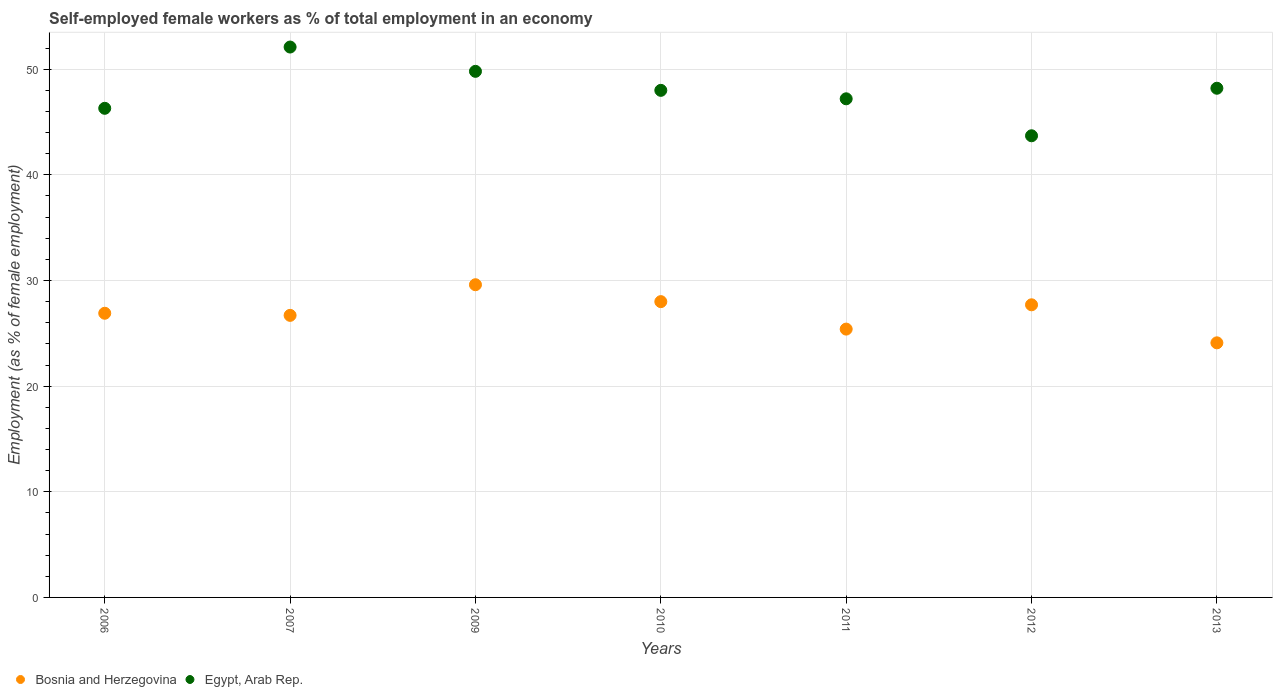How many different coloured dotlines are there?
Offer a very short reply. 2. What is the percentage of self-employed female workers in Egypt, Arab Rep. in 2006?
Give a very brief answer. 46.3. Across all years, what is the maximum percentage of self-employed female workers in Egypt, Arab Rep.?
Your response must be concise. 52.1. Across all years, what is the minimum percentage of self-employed female workers in Bosnia and Herzegovina?
Offer a very short reply. 24.1. In which year was the percentage of self-employed female workers in Egypt, Arab Rep. maximum?
Offer a very short reply. 2007. What is the total percentage of self-employed female workers in Bosnia and Herzegovina in the graph?
Keep it short and to the point. 188.4. What is the difference between the percentage of self-employed female workers in Bosnia and Herzegovina in 2007 and that in 2010?
Offer a very short reply. -1.3. What is the difference between the percentage of self-employed female workers in Bosnia and Herzegovina in 2006 and the percentage of self-employed female workers in Egypt, Arab Rep. in 2009?
Give a very brief answer. -22.9. What is the average percentage of self-employed female workers in Egypt, Arab Rep. per year?
Offer a terse response. 47.9. In the year 2007, what is the difference between the percentage of self-employed female workers in Bosnia and Herzegovina and percentage of self-employed female workers in Egypt, Arab Rep.?
Your answer should be compact. -25.4. In how many years, is the percentage of self-employed female workers in Bosnia and Herzegovina greater than 50 %?
Offer a terse response. 0. What is the ratio of the percentage of self-employed female workers in Egypt, Arab Rep. in 2009 to that in 2010?
Your answer should be very brief. 1.04. Is the difference between the percentage of self-employed female workers in Bosnia and Herzegovina in 2007 and 2013 greater than the difference between the percentage of self-employed female workers in Egypt, Arab Rep. in 2007 and 2013?
Your answer should be compact. No. What is the difference between the highest and the second highest percentage of self-employed female workers in Bosnia and Herzegovina?
Offer a terse response. 1.6. What is the difference between the highest and the lowest percentage of self-employed female workers in Egypt, Arab Rep.?
Ensure brevity in your answer.  8.4. Is the percentage of self-employed female workers in Bosnia and Herzegovina strictly greater than the percentage of self-employed female workers in Egypt, Arab Rep. over the years?
Your answer should be compact. No. How many years are there in the graph?
Provide a short and direct response. 7. Are the values on the major ticks of Y-axis written in scientific E-notation?
Keep it short and to the point. No. Does the graph contain any zero values?
Make the answer very short. No. Where does the legend appear in the graph?
Your response must be concise. Bottom left. How are the legend labels stacked?
Keep it short and to the point. Horizontal. What is the title of the graph?
Your response must be concise. Self-employed female workers as % of total employment in an economy. What is the label or title of the X-axis?
Your answer should be compact. Years. What is the label or title of the Y-axis?
Your response must be concise. Employment (as % of female employment). What is the Employment (as % of female employment) of Bosnia and Herzegovina in 2006?
Keep it short and to the point. 26.9. What is the Employment (as % of female employment) in Egypt, Arab Rep. in 2006?
Your answer should be very brief. 46.3. What is the Employment (as % of female employment) of Bosnia and Herzegovina in 2007?
Keep it short and to the point. 26.7. What is the Employment (as % of female employment) in Egypt, Arab Rep. in 2007?
Give a very brief answer. 52.1. What is the Employment (as % of female employment) in Bosnia and Herzegovina in 2009?
Offer a terse response. 29.6. What is the Employment (as % of female employment) of Egypt, Arab Rep. in 2009?
Give a very brief answer. 49.8. What is the Employment (as % of female employment) of Egypt, Arab Rep. in 2010?
Your response must be concise. 48. What is the Employment (as % of female employment) in Bosnia and Herzegovina in 2011?
Keep it short and to the point. 25.4. What is the Employment (as % of female employment) in Egypt, Arab Rep. in 2011?
Your answer should be compact. 47.2. What is the Employment (as % of female employment) in Bosnia and Herzegovina in 2012?
Your answer should be very brief. 27.7. What is the Employment (as % of female employment) in Egypt, Arab Rep. in 2012?
Your answer should be compact. 43.7. What is the Employment (as % of female employment) of Bosnia and Herzegovina in 2013?
Your response must be concise. 24.1. What is the Employment (as % of female employment) of Egypt, Arab Rep. in 2013?
Ensure brevity in your answer.  48.2. Across all years, what is the maximum Employment (as % of female employment) in Bosnia and Herzegovina?
Your response must be concise. 29.6. Across all years, what is the maximum Employment (as % of female employment) in Egypt, Arab Rep.?
Keep it short and to the point. 52.1. Across all years, what is the minimum Employment (as % of female employment) of Bosnia and Herzegovina?
Your answer should be compact. 24.1. Across all years, what is the minimum Employment (as % of female employment) of Egypt, Arab Rep.?
Your answer should be very brief. 43.7. What is the total Employment (as % of female employment) of Bosnia and Herzegovina in the graph?
Make the answer very short. 188.4. What is the total Employment (as % of female employment) of Egypt, Arab Rep. in the graph?
Your answer should be compact. 335.3. What is the difference between the Employment (as % of female employment) of Bosnia and Herzegovina in 2006 and that in 2007?
Provide a succinct answer. 0.2. What is the difference between the Employment (as % of female employment) of Bosnia and Herzegovina in 2006 and that in 2009?
Your response must be concise. -2.7. What is the difference between the Employment (as % of female employment) in Egypt, Arab Rep. in 2006 and that in 2009?
Offer a very short reply. -3.5. What is the difference between the Employment (as % of female employment) in Bosnia and Herzegovina in 2006 and that in 2010?
Keep it short and to the point. -1.1. What is the difference between the Employment (as % of female employment) in Bosnia and Herzegovina in 2006 and that in 2011?
Ensure brevity in your answer.  1.5. What is the difference between the Employment (as % of female employment) in Bosnia and Herzegovina in 2006 and that in 2012?
Make the answer very short. -0.8. What is the difference between the Employment (as % of female employment) of Bosnia and Herzegovina in 2006 and that in 2013?
Keep it short and to the point. 2.8. What is the difference between the Employment (as % of female employment) of Bosnia and Herzegovina in 2007 and that in 2009?
Provide a succinct answer. -2.9. What is the difference between the Employment (as % of female employment) of Egypt, Arab Rep. in 2007 and that in 2009?
Provide a short and direct response. 2.3. What is the difference between the Employment (as % of female employment) of Bosnia and Herzegovina in 2007 and that in 2011?
Offer a terse response. 1.3. What is the difference between the Employment (as % of female employment) in Bosnia and Herzegovina in 2007 and that in 2013?
Offer a very short reply. 2.6. What is the difference between the Employment (as % of female employment) in Egypt, Arab Rep. in 2007 and that in 2013?
Offer a terse response. 3.9. What is the difference between the Employment (as % of female employment) of Bosnia and Herzegovina in 2009 and that in 2010?
Offer a terse response. 1.6. What is the difference between the Employment (as % of female employment) of Egypt, Arab Rep. in 2009 and that in 2010?
Provide a succinct answer. 1.8. What is the difference between the Employment (as % of female employment) in Bosnia and Herzegovina in 2009 and that in 2011?
Offer a terse response. 4.2. What is the difference between the Employment (as % of female employment) of Bosnia and Herzegovina in 2009 and that in 2012?
Your answer should be compact. 1.9. What is the difference between the Employment (as % of female employment) of Bosnia and Herzegovina in 2010 and that in 2011?
Provide a short and direct response. 2.6. What is the difference between the Employment (as % of female employment) in Egypt, Arab Rep. in 2010 and that in 2011?
Offer a terse response. 0.8. What is the difference between the Employment (as % of female employment) of Egypt, Arab Rep. in 2010 and that in 2012?
Provide a succinct answer. 4.3. What is the difference between the Employment (as % of female employment) in Egypt, Arab Rep. in 2010 and that in 2013?
Your response must be concise. -0.2. What is the difference between the Employment (as % of female employment) of Bosnia and Herzegovina in 2011 and that in 2012?
Offer a very short reply. -2.3. What is the difference between the Employment (as % of female employment) of Egypt, Arab Rep. in 2011 and that in 2012?
Provide a short and direct response. 3.5. What is the difference between the Employment (as % of female employment) of Bosnia and Herzegovina in 2012 and that in 2013?
Offer a very short reply. 3.6. What is the difference between the Employment (as % of female employment) of Egypt, Arab Rep. in 2012 and that in 2013?
Your response must be concise. -4.5. What is the difference between the Employment (as % of female employment) in Bosnia and Herzegovina in 2006 and the Employment (as % of female employment) in Egypt, Arab Rep. in 2007?
Offer a very short reply. -25.2. What is the difference between the Employment (as % of female employment) of Bosnia and Herzegovina in 2006 and the Employment (as % of female employment) of Egypt, Arab Rep. in 2009?
Ensure brevity in your answer.  -22.9. What is the difference between the Employment (as % of female employment) of Bosnia and Herzegovina in 2006 and the Employment (as % of female employment) of Egypt, Arab Rep. in 2010?
Keep it short and to the point. -21.1. What is the difference between the Employment (as % of female employment) of Bosnia and Herzegovina in 2006 and the Employment (as % of female employment) of Egypt, Arab Rep. in 2011?
Provide a short and direct response. -20.3. What is the difference between the Employment (as % of female employment) in Bosnia and Herzegovina in 2006 and the Employment (as % of female employment) in Egypt, Arab Rep. in 2012?
Give a very brief answer. -16.8. What is the difference between the Employment (as % of female employment) in Bosnia and Herzegovina in 2006 and the Employment (as % of female employment) in Egypt, Arab Rep. in 2013?
Make the answer very short. -21.3. What is the difference between the Employment (as % of female employment) of Bosnia and Herzegovina in 2007 and the Employment (as % of female employment) of Egypt, Arab Rep. in 2009?
Give a very brief answer. -23.1. What is the difference between the Employment (as % of female employment) of Bosnia and Herzegovina in 2007 and the Employment (as % of female employment) of Egypt, Arab Rep. in 2010?
Your answer should be compact. -21.3. What is the difference between the Employment (as % of female employment) in Bosnia and Herzegovina in 2007 and the Employment (as % of female employment) in Egypt, Arab Rep. in 2011?
Provide a short and direct response. -20.5. What is the difference between the Employment (as % of female employment) of Bosnia and Herzegovina in 2007 and the Employment (as % of female employment) of Egypt, Arab Rep. in 2012?
Your answer should be compact. -17. What is the difference between the Employment (as % of female employment) in Bosnia and Herzegovina in 2007 and the Employment (as % of female employment) in Egypt, Arab Rep. in 2013?
Provide a short and direct response. -21.5. What is the difference between the Employment (as % of female employment) in Bosnia and Herzegovina in 2009 and the Employment (as % of female employment) in Egypt, Arab Rep. in 2010?
Provide a short and direct response. -18.4. What is the difference between the Employment (as % of female employment) of Bosnia and Herzegovina in 2009 and the Employment (as % of female employment) of Egypt, Arab Rep. in 2011?
Your answer should be very brief. -17.6. What is the difference between the Employment (as % of female employment) in Bosnia and Herzegovina in 2009 and the Employment (as % of female employment) in Egypt, Arab Rep. in 2012?
Offer a very short reply. -14.1. What is the difference between the Employment (as % of female employment) of Bosnia and Herzegovina in 2009 and the Employment (as % of female employment) of Egypt, Arab Rep. in 2013?
Provide a short and direct response. -18.6. What is the difference between the Employment (as % of female employment) of Bosnia and Herzegovina in 2010 and the Employment (as % of female employment) of Egypt, Arab Rep. in 2011?
Keep it short and to the point. -19.2. What is the difference between the Employment (as % of female employment) in Bosnia and Herzegovina in 2010 and the Employment (as % of female employment) in Egypt, Arab Rep. in 2012?
Ensure brevity in your answer.  -15.7. What is the difference between the Employment (as % of female employment) in Bosnia and Herzegovina in 2010 and the Employment (as % of female employment) in Egypt, Arab Rep. in 2013?
Ensure brevity in your answer.  -20.2. What is the difference between the Employment (as % of female employment) of Bosnia and Herzegovina in 2011 and the Employment (as % of female employment) of Egypt, Arab Rep. in 2012?
Your answer should be compact. -18.3. What is the difference between the Employment (as % of female employment) in Bosnia and Herzegovina in 2011 and the Employment (as % of female employment) in Egypt, Arab Rep. in 2013?
Keep it short and to the point. -22.8. What is the difference between the Employment (as % of female employment) in Bosnia and Herzegovina in 2012 and the Employment (as % of female employment) in Egypt, Arab Rep. in 2013?
Ensure brevity in your answer.  -20.5. What is the average Employment (as % of female employment) in Bosnia and Herzegovina per year?
Offer a very short reply. 26.91. What is the average Employment (as % of female employment) in Egypt, Arab Rep. per year?
Ensure brevity in your answer.  47.9. In the year 2006, what is the difference between the Employment (as % of female employment) in Bosnia and Herzegovina and Employment (as % of female employment) in Egypt, Arab Rep.?
Give a very brief answer. -19.4. In the year 2007, what is the difference between the Employment (as % of female employment) of Bosnia and Herzegovina and Employment (as % of female employment) of Egypt, Arab Rep.?
Give a very brief answer. -25.4. In the year 2009, what is the difference between the Employment (as % of female employment) of Bosnia and Herzegovina and Employment (as % of female employment) of Egypt, Arab Rep.?
Give a very brief answer. -20.2. In the year 2010, what is the difference between the Employment (as % of female employment) in Bosnia and Herzegovina and Employment (as % of female employment) in Egypt, Arab Rep.?
Offer a terse response. -20. In the year 2011, what is the difference between the Employment (as % of female employment) in Bosnia and Herzegovina and Employment (as % of female employment) in Egypt, Arab Rep.?
Your answer should be compact. -21.8. In the year 2012, what is the difference between the Employment (as % of female employment) of Bosnia and Herzegovina and Employment (as % of female employment) of Egypt, Arab Rep.?
Provide a short and direct response. -16. In the year 2013, what is the difference between the Employment (as % of female employment) of Bosnia and Herzegovina and Employment (as % of female employment) of Egypt, Arab Rep.?
Your response must be concise. -24.1. What is the ratio of the Employment (as % of female employment) in Bosnia and Herzegovina in 2006 to that in 2007?
Your answer should be very brief. 1.01. What is the ratio of the Employment (as % of female employment) in Egypt, Arab Rep. in 2006 to that in 2007?
Make the answer very short. 0.89. What is the ratio of the Employment (as % of female employment) in Bosnia and Herzegovina in 2006 to that in 2009?
Your response must be concise. 0.91. What is the ratio of the Employment (as % of female employment) of Egypt, Arab Rep. in 2006 to that in 2009?
Provide a succinct answer. 0.93. What is the ratio of the Employment (as % of female employment) of Bosnia and Herzegovina in 2006 to that in 2010?
Your answer should be very brief. 0.96. What is the ratio of the Employment (as % of female employment) of Egypt, Arab Rep. in 2006 to that in 2010?
Give a very brief answer. 0.96. What is the ratio of the Employment (as % of female employment) in Bosnia and Herzegovina in 2006 to that in 2011?
Offer a very short reply. 1.06. What is the ratio of the Employment (as % of female employment) of Egypt, Arab Rep. in 2006 to that in 2011?
Your answer should be compact. 0.98. What is the ratio of the Employment (as % of female employment) of Bosnia and Herzegovina in 2006 to that in 2012?
Ensure brevity in your answer.  0.97. What is the ratio of the Employment (as % of female employment) of Egypt, Arab Rep. in 2006 to that in 2012?
Your answer should be compact. 1.06. What is the ratio of the Employment (as % of female employment) in Bosnia and Herzegovina in 2006 to that in 2013?
Keep it short and to the point. 1.12. What is the ratio of the Employment (as % of female employment) in Egypt, Arab Rep. in 2006 to that in 2013?
Your response must be concise. 0.96. What is the ratio of the Employment (as % of female employment) of Bosnia and Herzegovina in 2007 to that in 2009?
Make the answer very short. 0.9. What is the ratio of the Employment (as % of female employment) in Egypt, Arab Rep. in 2007 to that in 2009?
Make the answer very short. 1.05. What is the ratio of the Employment (as % of female employment) in Bosnia and Herzegovina in 2007 to that in 2010?
Make the answer very short. 0.95. What is the ratio of the Employment (as % of female employment) of Egypt, Arab Rep. in 2007 to that in 2010?
Ensure brevity in your answer.  1.09. What is the ratio of the Employment (as % of female employment) in Bosnia and Herzegovina in 2007 to that in 2011?
Ensure brevity in your answer.  1.05. What is the ratio of the Employment (as % of female employment) in Egypt, Arab Rep. in 2007 to that in 2011?
Your response must be concise. 1.1. What is the ratio of the Employment (as % of female employment) of Bosnia and Herzegovina in 2007 to that in 2012?
Your answer should be compact. 0.96. What is the ratio of the Employment (as % of female employment) of Egypt, Arab Rep. in 2007 to that in 2012?
Give a very brief answer. 1.19. What is the ratio of the Employment (as % of female employment) in Bosnia and Herzegovina in 2007 to that in 2013?
Make the answer very short. 1.11. What is the ratio of the Employment (as % of female employment) in Egypt, Arab Rep. in 2007 to that in 2013?
Make the answer very short. 1.08. What is the ratio of the Employment (as % of female employment) of Bosnia and Herzegovina in 2009 to that in 2010?
Ensure brevity in your answer.  1.06. What is the ratio of the Employment (as % of female employment) in Egypt, Arab Rep. in 2009 to that in 2010?
Your answer should be compact. 1.04. What is the ratio of the Employment (as % of female employment) in Bosnia and Herzegovina in 2009 to that in 2011?
Give a very brief answer. 1.17. What is the ratio of the Employment (as % of female employment) in Egypt, Arab Rep. in 2009 to that in 2011?
Offer a terse response. 1.06. What is the ratio of the Employment (as % of female employment) in Bosnia and Herzegovina in 2009 to that in 2012?
Keep it short and to the point. 1.07. What is the ratio of the Employment (as % of female employment) of Egypt, Arab Rep. in 2009 to that in 2012?
Ensure brevity in your answer.  1.14. What is the ratio of the Employment (as % of female employment) of Bosnia and Herzegovina in 2009 to that in 2013?
Provide a succinct answer. 1.23. What is the ratio of the Employment (as % of female employment) in Egypt, Arab Rep. in 2009 to that in 2013?
Make the answer very short. 1.03. What is the ratio of the Employment (as % of female employment) of Bosnia and Herzegovina in 2010 to that in 2011?
Make the answer very short. 1.1. What is the ratio of the Employment (as % of female employment) in Egypt, Arab Rep. in 2010 to that in 2011?
Your answer should be compact. 1.02. What is the ratio of the Employment (as % of female employment) in Bosnia and Herzegovina in 2010 to that in 2012?
Offer a very short reply. 1.01. What is the ratio of the Employment (as % of female employment) of Egypt, Arab Rep. in 2010 to that in 2012?
Keep it short and to the point. 1.1. What is the ratio of the Employment (as % of female employment) of Bosnia and Herzegovina in 2010 to that in 2013?
Provide a short and direct response. 1.16. What is the ratio of the Employment (as % of female employment) of Bosnia and Herzegovina in 2011 to that in 2012?
Provide a succinct answer. 0.92. What is the ratio of the Employment (as % of female employment) in Egypt, Arab Rep. in 2011 to that in 2012?
Ensure brevity in your answer.  1.08. What is the ratio of the Employment (as % of female employment) in Bosnia and Herzegovina in 2011 to that in 2013?
Offer a very short reply. 1.05. What is the ratio of the Employment (as % of female employment) in Egypt, Arab Rep. in 2011 to that in 2013?
Give a very brief answer. 0.98. What is the ratio of the Employment (as % of female employment) of Bosnia and Herzegovina in 2012 to that in 2013?
Provide a succinct answer. 1.15. What is the ratio of the Employment (as % of female employment) of Egypt, Arab Rep. in 2012 to that in 2013?
Your response must be concise. 0.91. What is the difference between the highest and the lowest Employment (as % of female employment) of Bosnia and Herzegovina?
Give a very brief answer. 5.5. What is the difference between the highest and the lowest Employment (as % of female employment) of Egypt, Arab Rep.?
Provide a succinct answer. 8.4. 